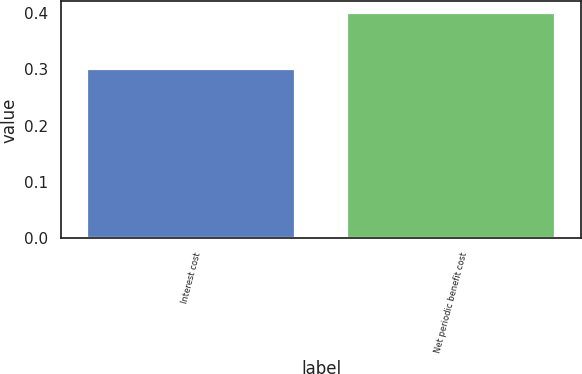Convert chart. <chart><loc_0><loc_0><loc_500><loc_500><bar_chart><fcel>Interest cost<fcel>Net periodic benefit cost<nl><fcel>0.3<fcel>0.4<nl></chart> 